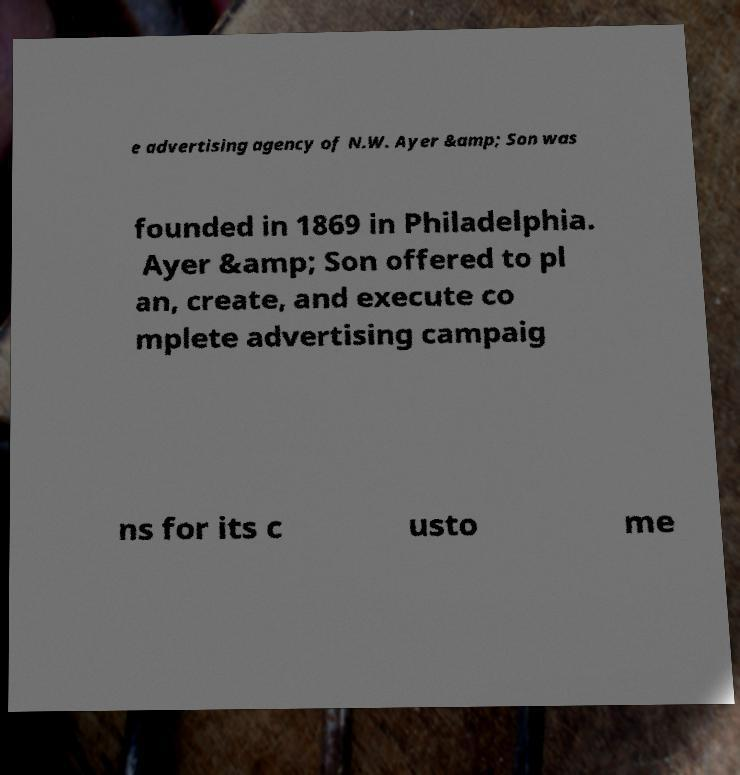There's text embedded in this image that I need extracted. Can you transcribe it verbatim? e advertising agency of N.W. Ayer &amp; Son was founded in 1869 in Philadelphia. Ayer &amp; Son offered to pl an, create, and execute co mplete advertising campaig ns for its c usto me 